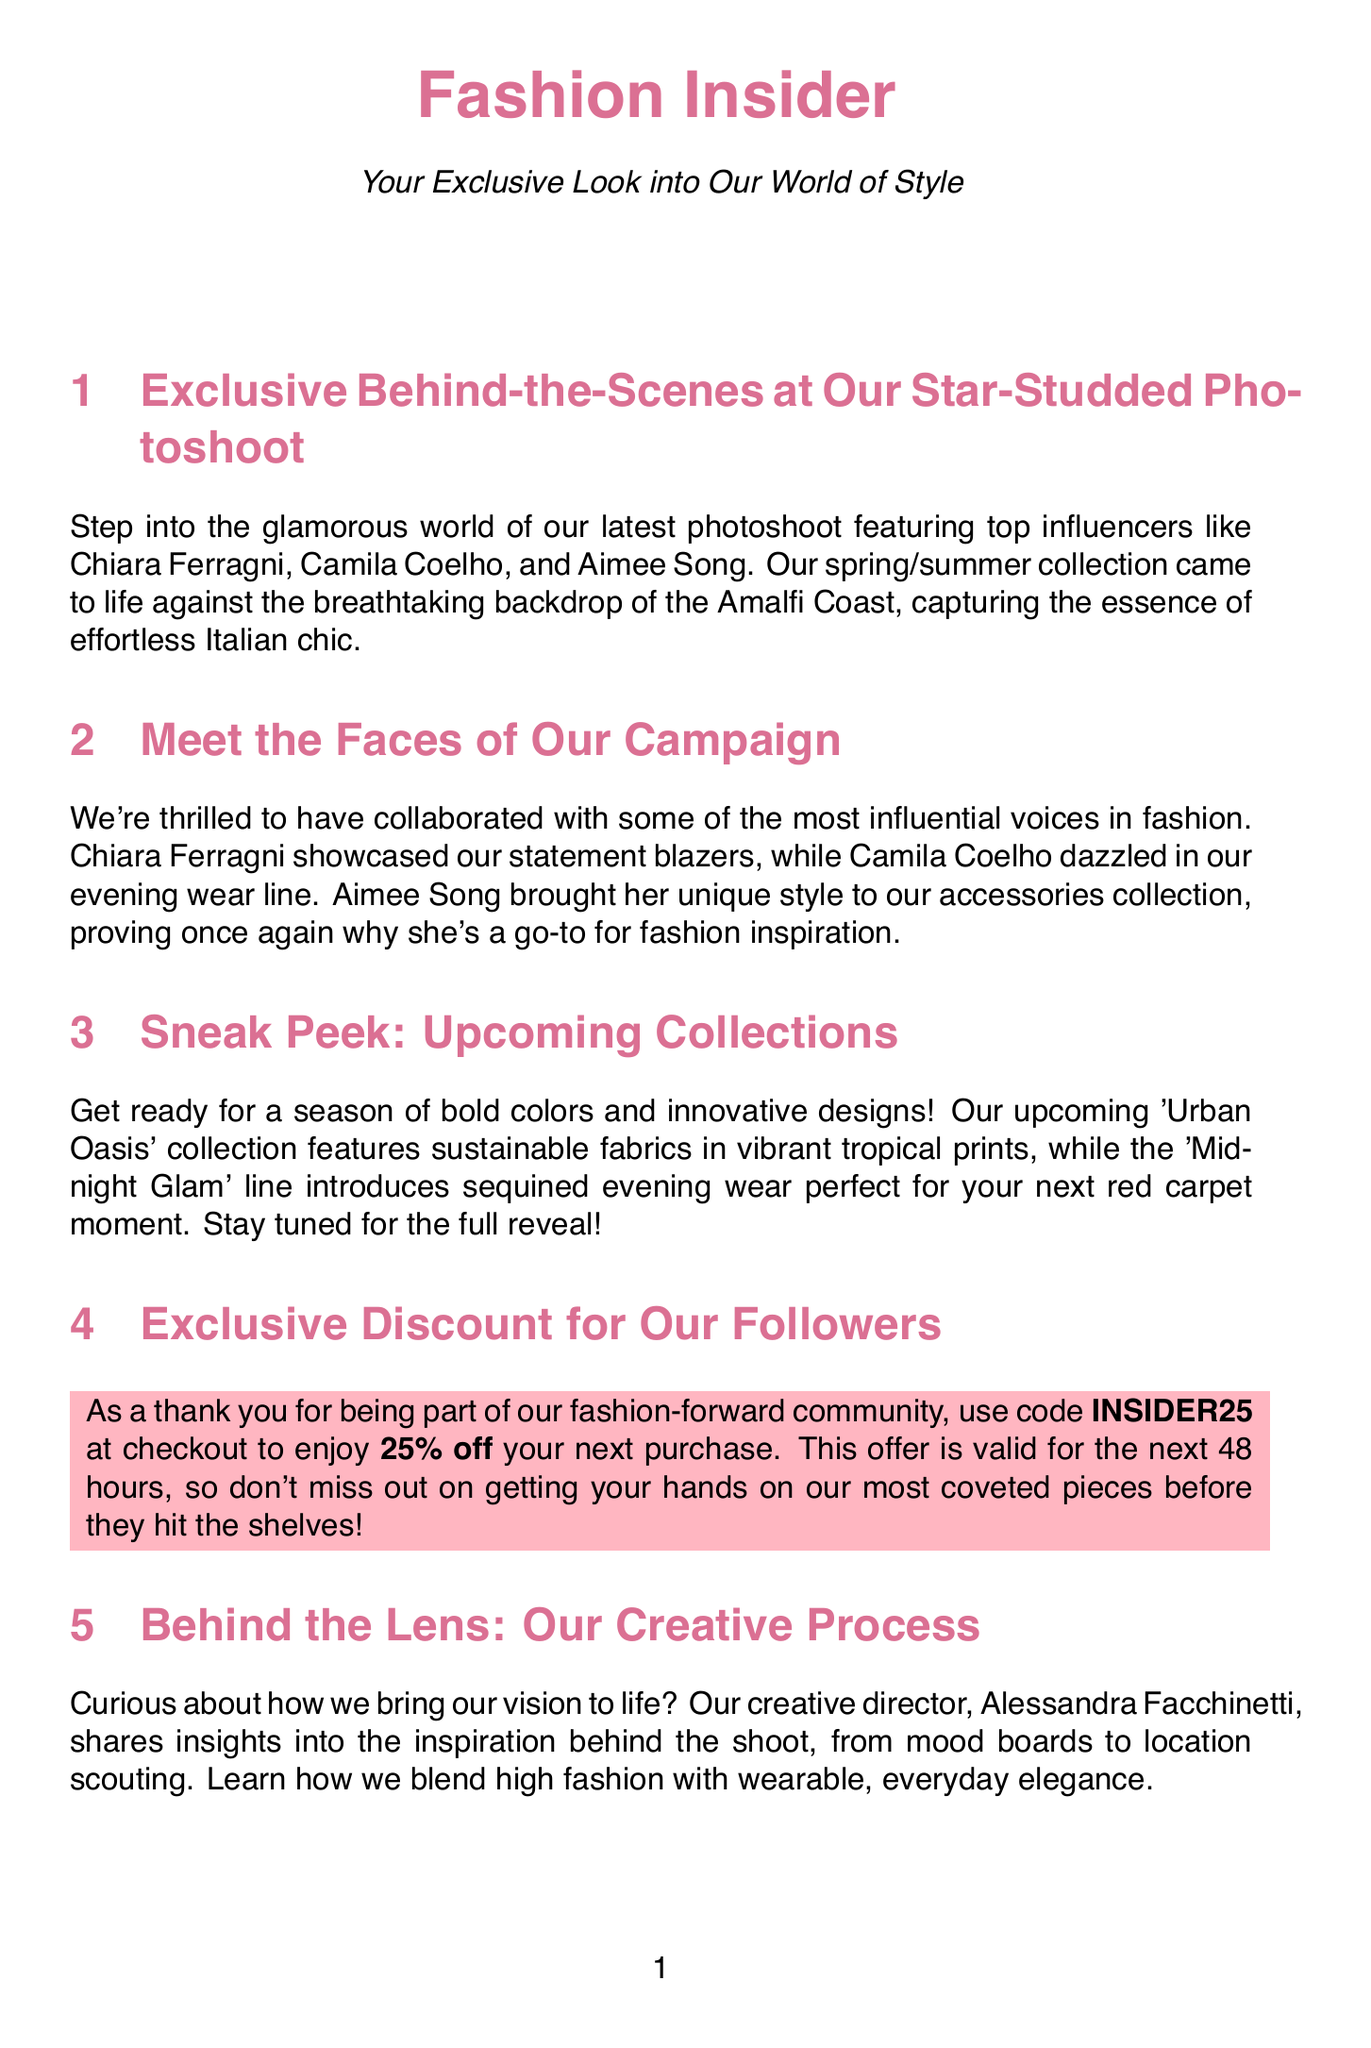What influencers were featured in the photoshoot? The document lists the top influencers who participated in the photoshoot as Chiara Ferragni, Camila Coelho, and Aimee Song.
Answer: Chiara Ferragni, Camila Coelho, Aimee Song What is the location of the latest photoshoot? The photoshoot backdrop is specified as the Amalfi Coast, which is mentioned in the description of the event.
Answer: Amalfi Coast What code should followers use for a discount? The newsletter provides a specific code for followers to use which is designed for the mentioned discount offer.
Answer: INSIDER25 How much discount can followers get with the code? The document states the percentage discount available when using the provided code during checkout.
Answer: 25% When is the exclusive pre-sale event scheduled? The newsletter explicitly mentions the date of the pre-sale event which is for newsletter subscribers.
Answer: May 15th What will be the focus of the 'Urban Oasis' collection? The document explains that the 'Urban Oasis' collection will feature specific elements related to its design and materials.
Answer: Sustainable fabrics in vibrant tropical prints Who is the creative director mentioned in the newsletter? The creative director responsible for insights and vision behind the shoot is identified in the document.
Answer: Alessandra Facchinetti What type of fabrics is used in the swimwear line? It is indicated in the sustainability section that regenerated materials are used in the swimwear collection.
Answer: Regenerated nylon fibers What is the expiration time for the discount offer? The document specifies the validity period of the discount offer following its announcement.
Answer: 48 hours 